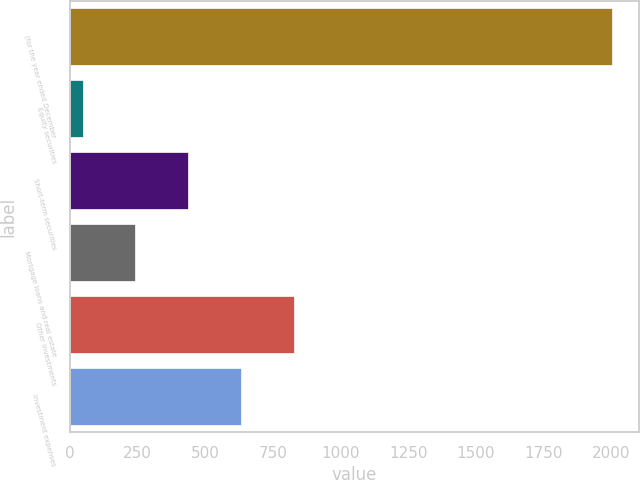Convert chart to OTSL. <chart><loc_0><loc_0><loc_500><loc_500><bar_chart><fcel>(for the year ended December<fcel>Equity securities<fcel>Short-term securities<fcel>Mortgage loans and real estate<fcel>Other investments<fcel>Investment expenses<nl><fcel>2004<fcel>47<fcel>438.4<fcel>242.7<fcel>829.8<fcel>634.1<nl></chart> 